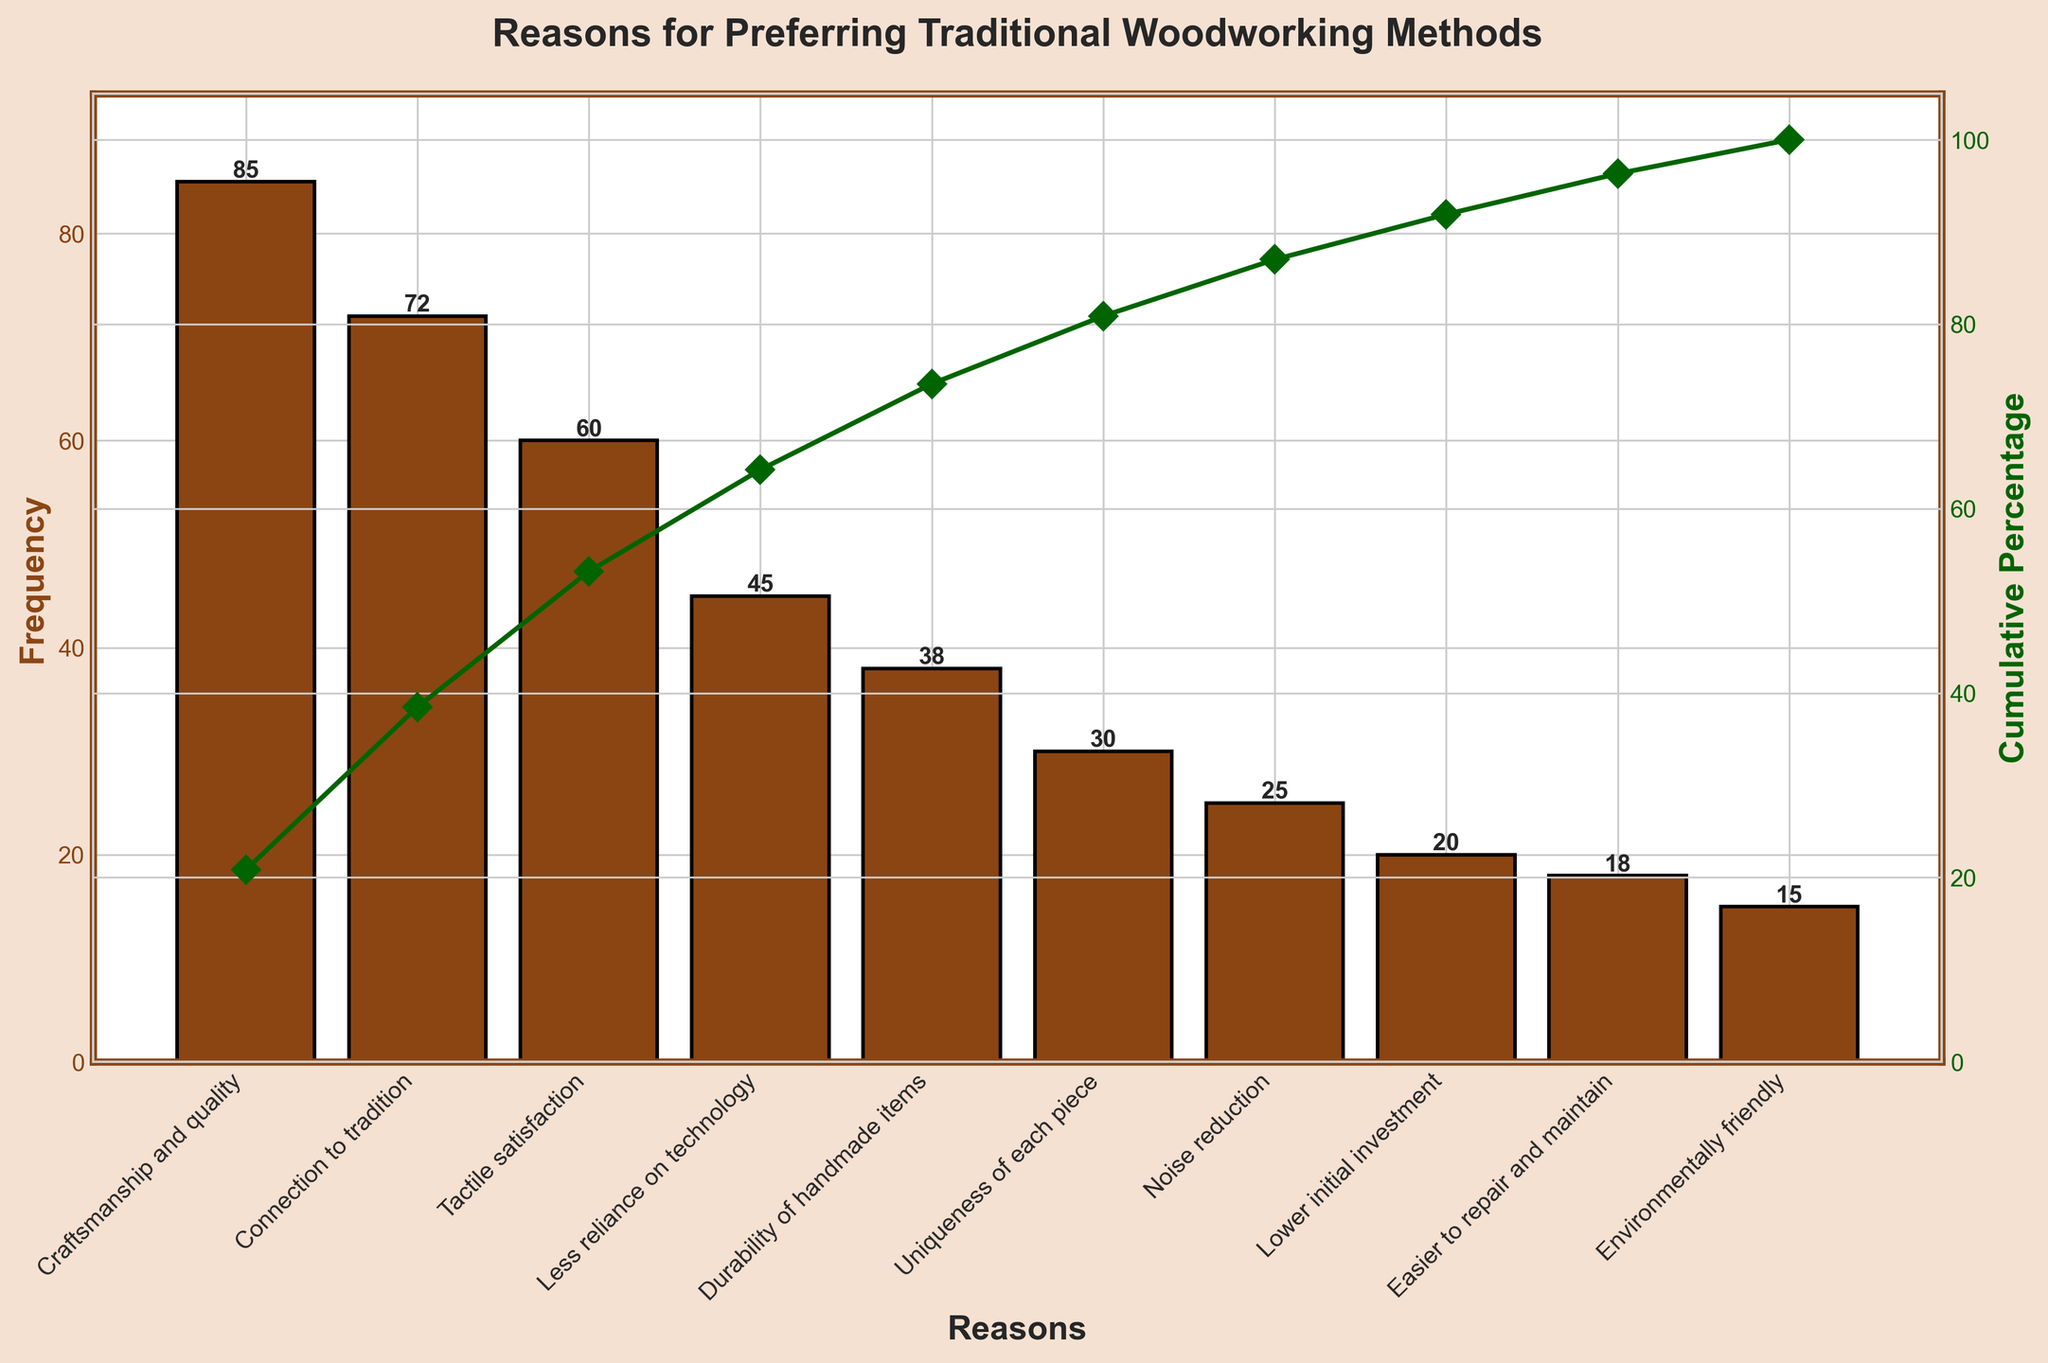What's the most frequent reason for preferring traditional woodworking methods? The most frequent reason is the one with the highest bar length in the bar plot. According to the data, "Craftsmanship and quality" has the highest frequency of 85.
Answer: Craftsmanship and quality What is the cumulative percentage when including the top three reasons? The cumulative percentage is shown by the line plot. By adding the first three bars ("Craftsmanship and quality", "Connection to tradition", and "Tactile satisfaction"), we get 85 + 72 + 60 = 217. Then, compute the cumulative percentage: (217 / (85 + 72 + 60 + 45 + 38 + 30 + 25 + 20 + 18 + 15)) * 100 ≈ 72.5%.
Answer: 72.5% How many reasons have a frequency under 30? Count the number of bars with heights less than 30 on the bar plot. The bars "Noise reduction" (25), "Lower initial investment" (20), "Easier to repair and maintain" (18), and "Environmentally friendly" (15) are under 30 in height.
Answer: 4 Which reason has a frequency exactly 30? Find the bar on the plot with a height of 30. According to the data, "Uniqueness of each piece" has a frequency of 30.
Answer: Uniqueness of each piece Which reasons together account for about half of the total frequency? You need to find the reasons that together sum up to around half of the total frequency. Start adding the frequencies from the top until you reach the approximate half of the total sum (203/2 ≈ 101.5). The reasons "Craftsmanship and quality" (85) and "Connection to tradition" (72) together sum up to 157, which is more than 101.5 but closer than other combinations.
Answer: Craftsmanship and quality, Connection to tradition What is the title of the chart? The title is the large text displayed at the top of the figure. It reads, "Reasons for Preferring Traditional Woodworking Methods".
Answer: Reasons for Preferring Traditional Woodworking Methods Between "Tactile satisfaction" and "Less reliance on technology", which is more significant, and by how much? Look at the bars for "Tactile satisfaction" and "Less reliance on technology". "Tactile satisfaction" has a frequency of 60 and "Less reliance on technology" has a frequency of 45. The difference is 60 - 45 = 15.
Answer: Tactile satisfaction by 15 By what cumulative percentage does "Craftsmanship and quality" surpass other reasons when it's the only one considered? The cumulative percentage of "Craftsmanship and quality" is simply (85 / 203) * 100 ≈ 41.9%.
Answer: 41.9% What is the color of the line representing the cumulative percentage in the plot? The color of the line plot for cumulative percentage is described as "dark green" in the explanation.
Answer: Dark green 